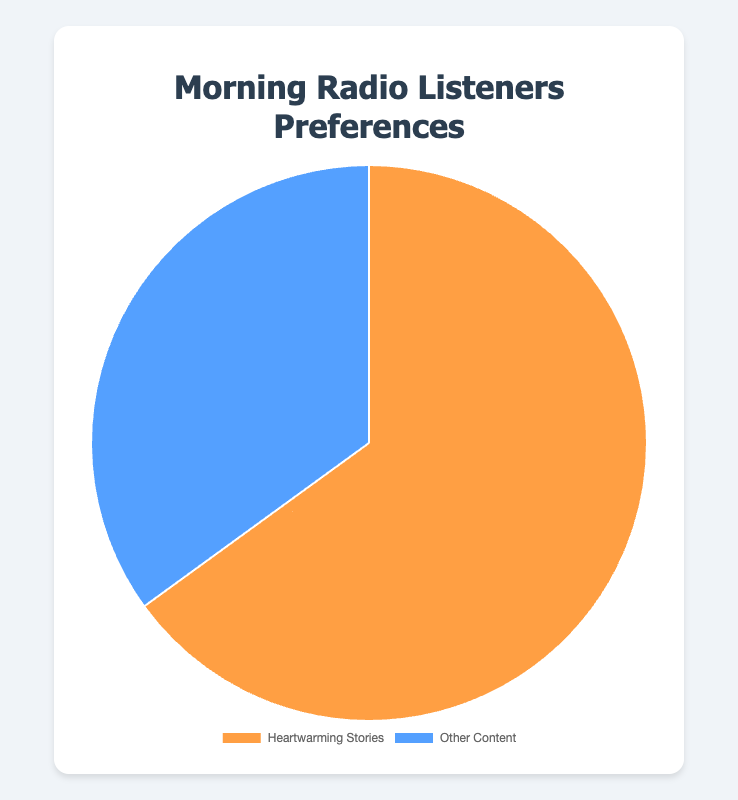What percentage of morning radio listeners prefer heartwarming stories? Look at the slice labeled 'Heartwarming Stories' in the pie chart. The figure indicates that 65% of the listeners prefer heartwarming stories.
Answer: 65% What percentage of morning radio listeners prefer other content? Look at the slice labeled 'Other Content' in the pie chart. The figure indicates that 35% of the listeners prefer other content.
Answer: 35% How much larger is the percentage of listeners who prefer heartwarming stories compared to those who prefer other content? Subtract the percentage of listeners who prefer other content (35%) from those who prefer heartwarming stories (65%). Calculation: 65% - 35% = 30%.
Answer: 30% What is the total percentage represented by both segments in the pie chart? Add the percentages of both segments together. Calculation: 65% + 35% = 100%.
Answer: 100% Which segment has a larger percentage of listeners, and by how much? Compare the percentages of the two segments. Heartwarming Stories have 65%, and Other Content has 35%. Subtract 35% from 65% to find the difference. Calculation: 65% - 35% = 30%.
Answer: Heartwarming Stories by 30% What is the ratio of listeners who prefer heartwarming stories to those who prefer other content? Divide the percentage of listeners who prefer heartwarming stories by the percentage of those who prefer other content. Calculation: 65 / 35 ≈ 1.86.
Answer: 1.86 By what factor is the preference for heartwarming stories greater than the preference for other content? Divide the percentage for heartwarming stories by the percentage for other content. Calculation: 65% / 35% ≈ 1.86.
Answer: 1.86 What is the combined percentage of listeners who prefer either heartwarming stories or other content in the morning? Add the percentages of listeners for both heartwarming stories and other content. Calculation: 65% + 35% = 100%.
Answer: 100% If you combine both segments, what fraction of the total do listeners of other content represent? Express the percentage of listeners who prefer other content as a fraction of the total 100%. Calculation: 35% / 100% = 0.35 or 35/100.
Answer: 35/100 